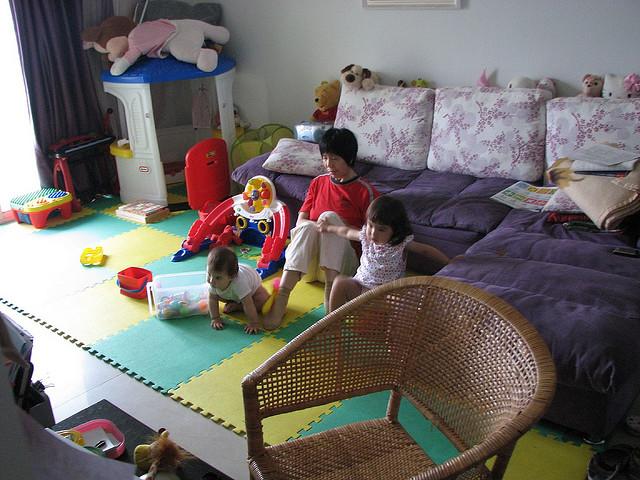What room is this?
Write a very short answer. Living room. How many pillows are on the couch?
Short answer required. 4. How many humans are in the picture?
Concise answer only. 3. 